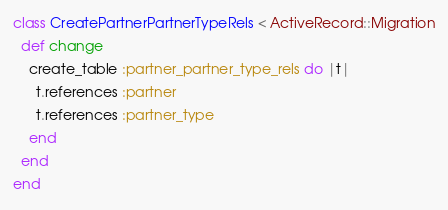<code> <loc_0><loc_0><loc_500><loc_500><_Ruby_>class CreatePartnerPartnerTypeRels < ActiveRecord::Migration
  def change
    create_table :partner_partner_type_rels do |t|
      t.references :partner
      t.references :partner_type
    end
  end
end
</code> 